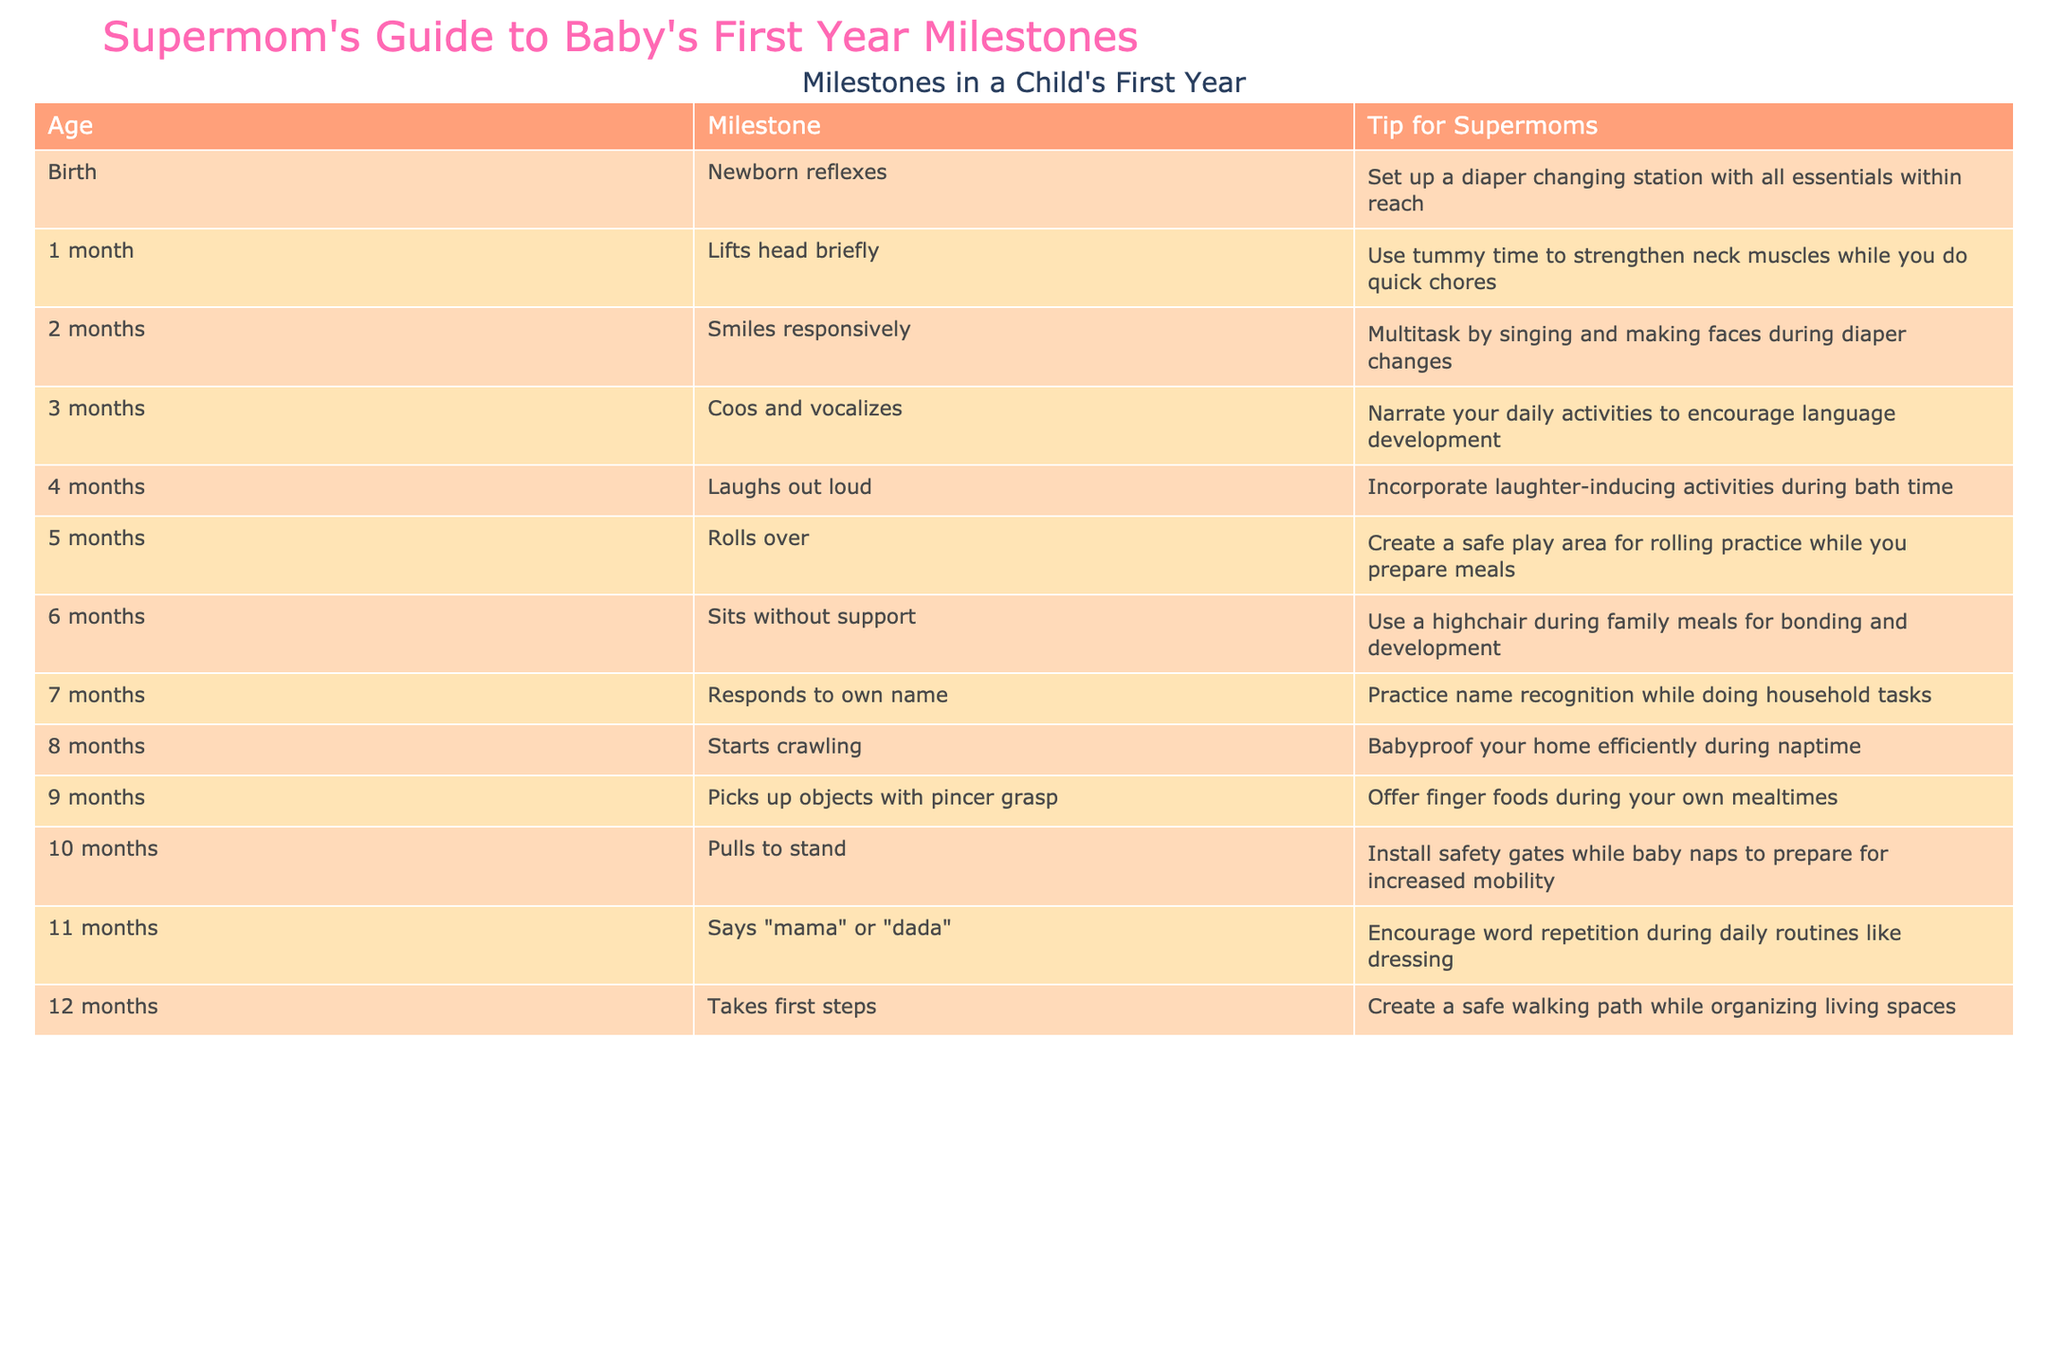What is the milestone achieved at 6 months? According to the table, at 6 months, the milestone is "Sits without support". This information can be found directly in the row corresponding to the 6-month age marker.
Answer: Sits without support How many milestones are achieved in the first year? By counting the number of ages listed in the table (from birth to 12 months), there are 12 milestones in total. Each month corresponds to one milestone, so simply counting the entries gives us the total.
Answer: 12 Is crawling a milestone that occurs before or after sitting without support? Referring to the table, crawling (which occurs at 8 months) happens after sitting without support (which occurs at 6 months). This requires a comparison of the ages in the respective rows for the milestones.
Answer: After At what age does a baby typically laugh out loud, and what practical tip is provided for that milestone? According to the table, a baby typically laughs out loud at 4 months. The associated tip is to incorporate laughter-inducing activities during bath time. This information is gathered by finding the milestone and its related tip in the table.
Answer: 4 months; incorporate laughter-inducing activities during bath time What is the average age at which a child achieves the first three milestones in the table? The first three milestones occur at 0 months (newborn reflexes), 1 month (lifts head briefly), and 2 months (smiles responsively). To find the average, we add these ages (0 + 1 + 2) = 3 and divide by 3 (the number of entries): 3/3 = 1. This calculation involves both addition and division based on the ages given in the first three rows.
Answer: 1 month Does the milestone for pulling to stand come before or after the milestone for taking first steps? The milestone for pulling to stand occurs at 10 months, while taking first steps occurs at 12 months. Therefore, pulling to stand comes before taking the first steps. This involves comparing the entries for those two milestones in the table.
Answer: Before Which milestone is related to the ability to pick up objects with a pincer grasp and what age does it occur? The milestone for picking up objects with a pincer grasp occurs at 9 months, as listed in the table. The age and the milestone are mentioned together in the corresponding row, indicating their association.
Answer: 9 months How many milestones involve vocalization in the first year, and what are they? The milestones involving vocalization are "Coos and vocalizes" at 3 months and "Says 'mama' or 'dada'" at 11 months, making a total of 2. Identifying these milestones requires referencing their descriptions in the table and comparing them based on the aspects of vocalization.
Answer: 2: Coos and vocalizes; Says 'mama' or 'dada' 